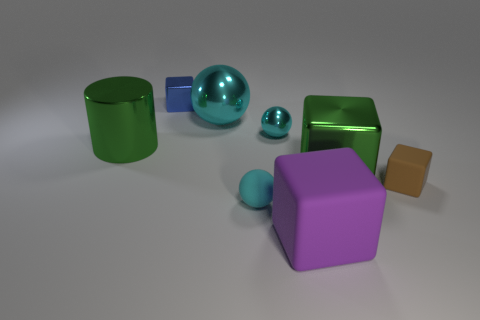Do the large green cylinder and the tiny blue thing have the same material?
Make the answer very short. Yes. What size is the shiny thing that is the same color as the large cylinder?
Your response must be concise. Large. Are there any tiny balls of the same color as the large shiny sphere?
Your answer should be very brief. Yes. The purple block that is the same material as the tiny brown block is what size?
Provide a short and direct response. Large. There is a green metal thing that is to the left of the metallic block right of the tiny cube behind the big metallic sphere; what shape is it?
Provide a succinct answer. Cylinder. What is the size of the green metallic object that is the same shape as the small brown rubber thing?
Provide a succinct answer. Large. There is a matte thing that is both to the right of the cyan matte object and in front of the small brown block; how big is it?
Keep it short and to the point. Large. There is a large shiny thing that is the same color as the large cylinder; what is its shape?
Make the answer very short. Cube. The large metallic ball has what color?
Offer a very short reply. Cyan. There is a rubber cube that is to the left of the brown cube; how big is it?
Provide a short and direct response. Large. 